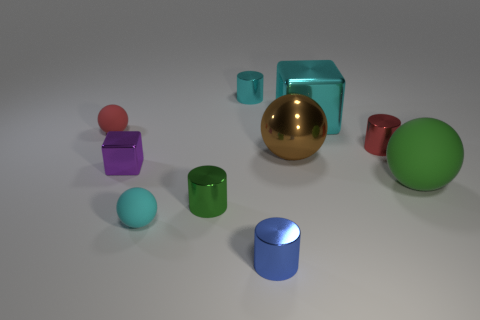Subtract all cyan balls. How many balls are left? 3 Subtract 2 balls. How many balls are left? 2 Subtract all gray cylinders. Subtract all blue balls. How many cylinders are left? 4 Subtract all balls. How many objects are left? 6 Add 7 red cylinders. How many red cylinders exist? 8 Subtract 0 gray balls. How many objects are left? 10 Subtract all brown cylinders. Subtract all large metal cubes. How many objects are left? 9 Add 4 large shiny objects. How many large shiny objects are left? 6 